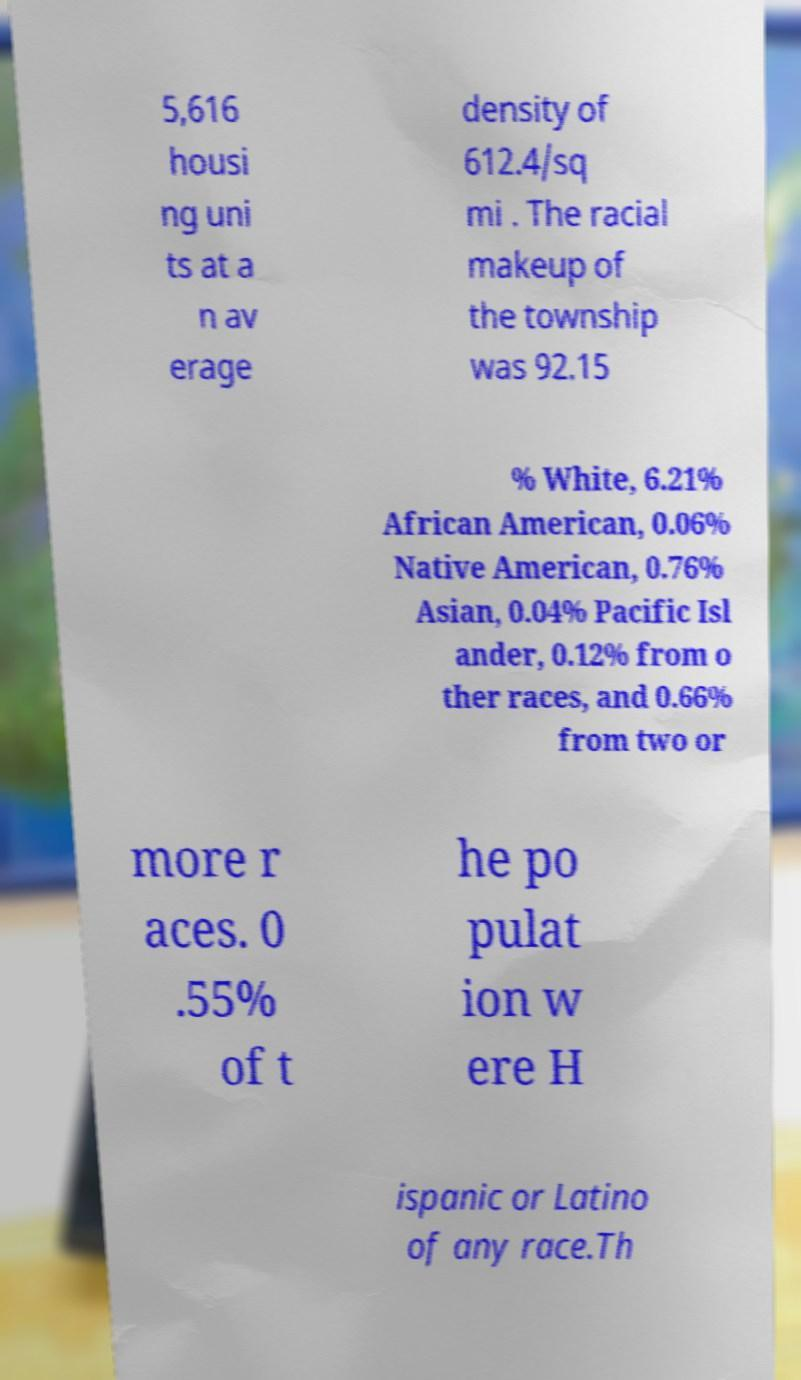Please identify and transcribe the text found in this image. 5,616 housi ng uni ts at a n av erage density of 612.4/sq mi . The racial makeup of the township was 92.15 % White, 6.21% African American, 0.06% Native American, 0.76% Asian, 0.04% Pacific Isl ander, 0.12% from o ther races, and 0.66% from two or more r aces. 0 .55% of t he po pulat ion w ere H ispanic or Latino of any race.Th 